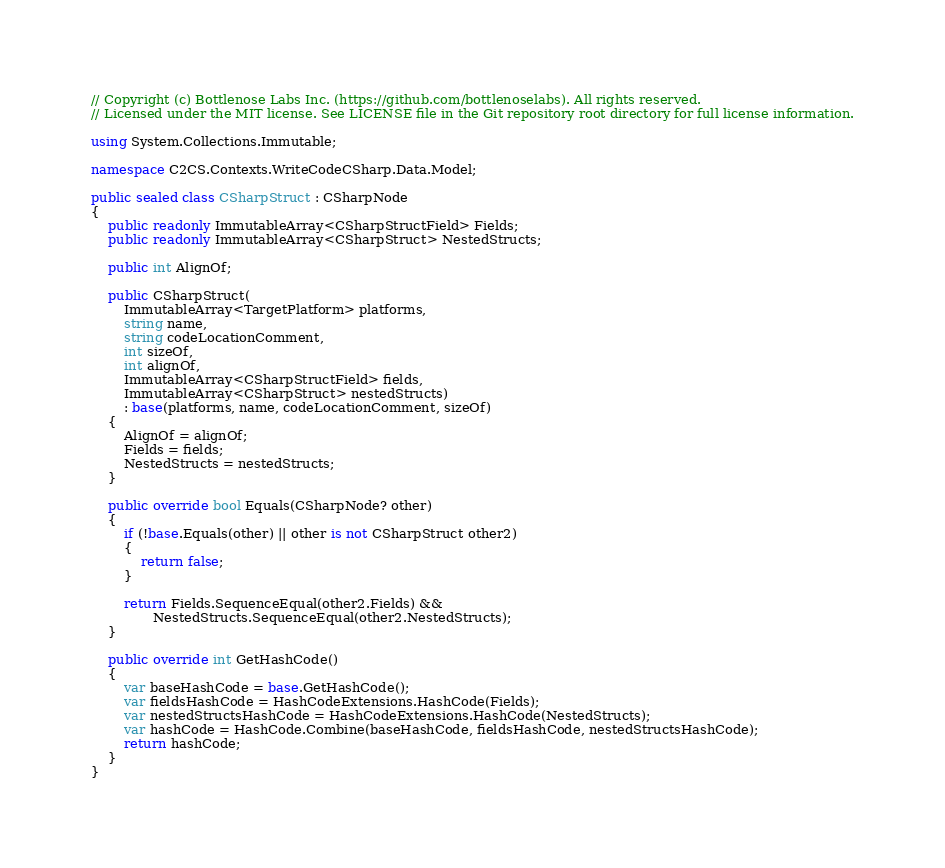<code> <loc_0><loc_0><loc_500><loc_500><_C#_>// Copyright (c) Bottlenose Labs Inc. (https://github.com/bottlenoselabs). All rights reserved.
// Licensed under the MIT license. See LICENSE file in the Git repository root directory for full license information.

using System.Collections.Immutable;

namespace C2CS.Contexts.WriteCodeCSharp.Data.Model;

public sealed class CSharpStruct : CSharpNode
{
    public readonly ImmutableArray<CSharpStructField> Fields;
    public readonly ImmutableArray<CSharpStruct> NestedStructs;

    public int AlignOf;

    public CSharpStruct(
        ImmutableArray<TargetPlatform> platforms,
        string name,
        string codeLocationComment,
        int sizeOf,
        int alignOf,
        ImmutableArray<CSharpStructField> fields,
        ImmutableArray<CSharpStruct> nestedStructs)
        : base(platforms, name, codeLocationComment, sizeOf)
    {
        AlignOf = alignOf;
        Fields = fields;
        NestedStructs = nestedStructs;
    }

    public override bool Equals(CSharpNode? other)
    {
        if (!base.Equals(other) || other is not CSharpStruct other2)
        {
            return false;
        }

        return Fields.SequenceEqual(other2.Fields) &&
               NestedStructs.SequenceEqual(other2.NestedStructs);
    }

    public override int GetHashCode()
    {
        var baseHashCode = base.GetHashCode();
        var fieldsHashCode = HashCodeExtensions.HashCode(Fields);
        var nestedStructsHashCode = HashCodeExtensions.HashCode(NestedStructs);
        var hashCode = HashCode.Combine(baseHashCode, fieldsHashCode, nestedStructsHashCode);
        return hashCode;
    }
}
</code> 